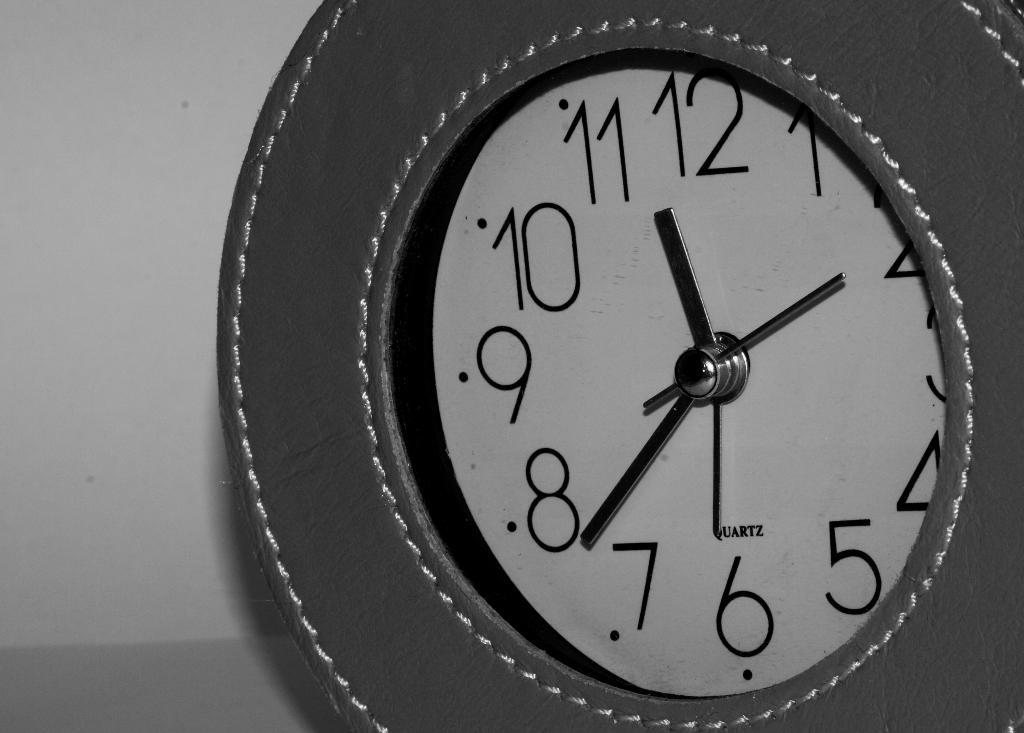<image>
Render a clear and concise summary of the photo. A white and black clock set to 11:38. 